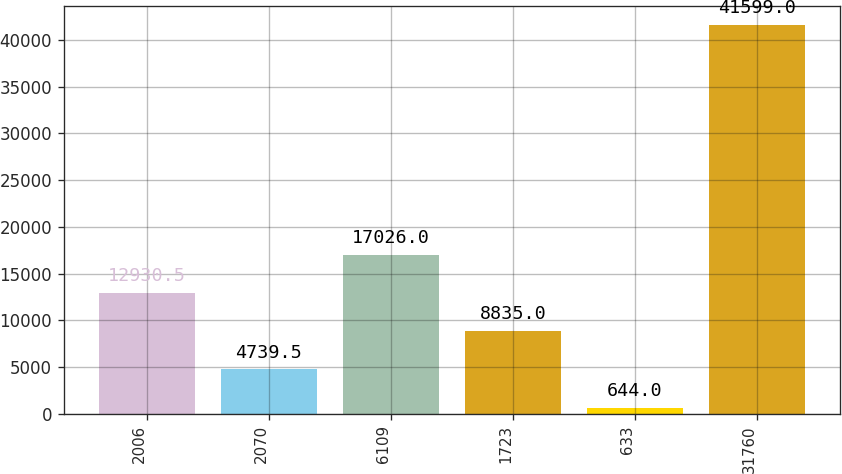Convert chart. <chart><loc_0><loc_0><loc_500><loc_500><bar_chart><fcel>2006<fcel>2070<fcel>6109<fcel>1723<fcel>633<fcel>31760<nl><fcel>12930.5<fcel>4739.5<fcel>17026<fcel>8835<fcel>644<fcel>41599<nl></chart> 